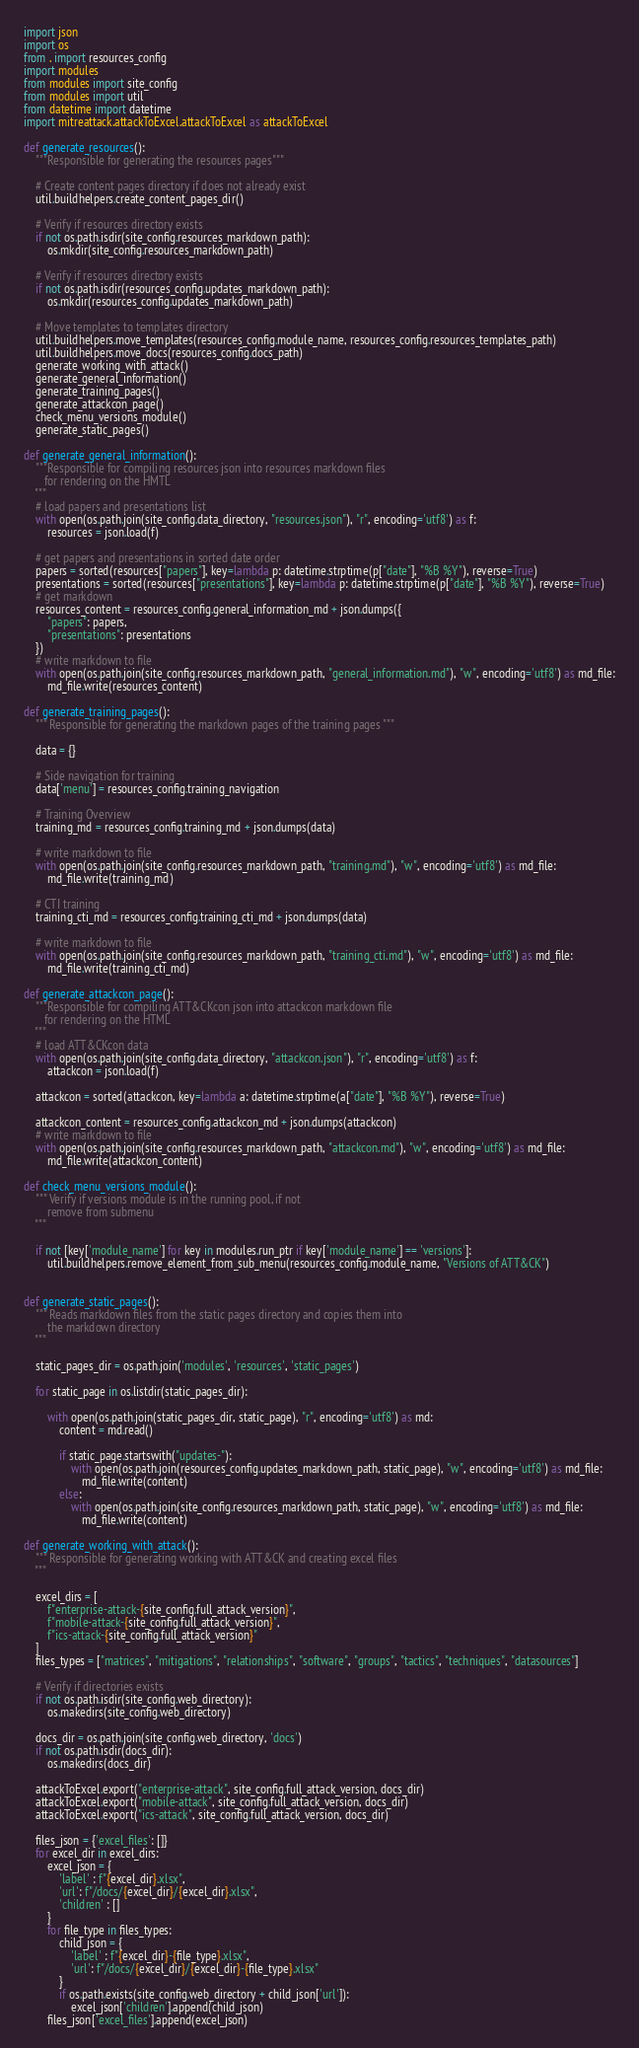Convert code to text. <code><loc_0><loc_0><loc_500><loc_500><_Python_>import json
import os
from . import resources_config
import modules
from modules import site_config
from modules import util
from datetime import datetime
import mitreattack.attackToExcel.attackToExcel as attackToExcel

def generate_resources():
    """Responsible for generating the resources pages"""

    # Create content pages directory if does not already exist
    util.buildhelpers.create_content_pages_dir()

    # Verify if resources directory exists
    if not os.path.isdir(site_config.resources_markdown_path):
        os.mkdir(site_config.resources_markdown_path)

    # Verify if resources directory exists
    if not os.path.isdir(resources_config.updates_markdown_path):
        os.mkdir(resources_config.updates_markdown_path)

    # Move templates to templates directory
    util.buildhelpers.move_templates(resources_config.module_name, resources_config.resources_templates_path)
    util.buildhelpers.move_docs(resources_config.docs_path)
    generate_working_with_attack()
    generate_general_information()
    generate_training_pages()
    generate_attackcon_page()
    check_menu_versions_module()
    generate_static_pages()

def generate_general_information():
    """Responsible for compiling resources json into resources markdown files
       for rendering on the HMTL
    """
    # load papers and presentations list
    with open(os.path.join(site_config.data_directory, "resources.json"), "r", encoding='utf8') as f:
        resources = json.load(f)
    
    # get papers and presentations in sorted date order
    papers = sorted(resources["papers"], key=lambda p: datetime.strptime(p["date"], "%B %Y"), reverse=True)
    presentations = sorted(resources["presentations"], key=lambda p: datetime.strptime(p["date"], "%B %Y"), reverse=True)
    # get markdown
    resources_content = resources_config.general_information_md + json.dumps({
        "papers": papers,
        "presentations": presentations
    })
    # write markdown to file
    with open(os.path.join(site_config.resources_markdown_path, "general_information.md"), "w", encoding='utf8') as md_file:
        md_file.write(resources_content)

def generate_training_pages():
    """ Responsible for generating the markdown pages of the training pages """

    data = {}
    
    # Side navigation for training
    data['menu'] = resources_config.training_navigation

    # Training Overview
    training_md = resources_config.training_md + json.dumps(data)

    # write markdown to file
    with open(os.path.join(site_config.resources_markdown_path, "training.md"), "w", encoding='utf8') as md_file:
        md_file.write(training_md)

    # CTI training
    training_cti_md = resources_config.training_cti_md + json.dumps(data)

    # write markdown to file
    with open(os.path.join(site_config.resources_markdown_path, "training_cti.md"), "w", encoding='utf8') as md_file:
        md_file.write(training_cti_md)

def generate_attackcon_page():
    """Responsible for compiling ATT&CKcon json into attackcon markdown file
       for rendering on the HTML
    """
    # load ATT&CKcon data
    with open(os.path.join(site_config.data_directory, "attackcon.json"), "r", encoding='utf8') as f:
        attackcon = json.load(f)

    attackcon = sorted(attackcon, key=lambda a: datetime.strptime(a["date"], "%B %Y"), reverse=True)

    attackcon_content = resources_config.attackcon_md + json.dumps(attackcon)
    # write markdown to file
    with open(os.path.join(site_config.resources_markdown_path, "attackcon.md"), "w", encoding='utf8') as md_file:
        md_file.write(attackcon_content)

def check_menu_versions_module():
    """ Verify if versions module is in the running pool, if not 
        remove from submenu 
    """

    if not [key['module_name'] for key in modules.run_ptr if key['module_name'] == 'versions']:
        util.buildhelpers.remove_element_from_sub_menu(resources_config.module_name, "Versions of ATT&CK")


def generate_static_pages():
    """ Reads markdown files from the static pages directory and copies them into 
        the markdown directory
    """

    static_pages_dir = os.path.join('modules', 'resources', 'static_pages')

    for static_page in os.listdir(static_pages_dir):

        with open(os.path.join(static_pages_dir, static_page), "r", encoding='utf8') as md:
            content = md.read()

            if static_page.startswith("updates-"):
                with open(os.path.join(resources_config.updates_markdown_path, static_page), "w", encoding='utf8') as md_file:
                    md_file.write(content)
            else:
                with open(os.path.join(site_config.resources_markdown_path, static_page), "w", encoding='utf8') as md_file:
                    md_file.write(content)

def generate_working_with_attack():
    """ Responsible for generating working with ATT&CK and creating excel files
    """

    excel_dirs = [
        f"enterprise-attack-{site_config.full_attack_version}", 
        f"mobile-attack-{site_config.full_attack_version}",
        f"ics-attack-{site_config.full_attack_version}"
    ]
    files_types = ["matrices", "mitigations", "relationships", "software", "groups", "tactics", "techniques", "datasources"]

    # Verify if directories exists
    if not os.path.isdir(site_config.web_directory):
        os.makedirs(site_config.web_directory)
    
    docs_dir = os.path.join(site_config.web_directory, 'docs')
    if not os.path.isdir(docs_dir):
        os.makedirs(docs_dir)

    attackToExcel.export("enterprise-attack", site_config.full_attack_version, docs_dir)
    attackToExcel.export("mobile-attack", site_config.full_attack_version, docs_dir)
    attackToExcel.export("ics-attack", site_config.full_attack_version, docs_dir)

    files_json = {'excel_files': []}
    for excel_dir in excel_dirs:
        excel_json = {
            'label' : f"{excel_dir}.xlsx",
            'url': f"/docs/{excel_dir}/{excel_dir}.xlsx",
            'children' : []
        }
        for file_type in files_types:
            child_json = {
                'label' : f"{excel_dir}-{file_type}.xlsx",
                'url': f"/docs/{excel_dir}/{excel_dir}-{file_type}.xlsx"
            }
            if os.path.exists(site_config.web_directory + child_json['url']):
                excel_json['children'].append(child_json)
        files_json['excel_files'].append(excel_json)
</code> 